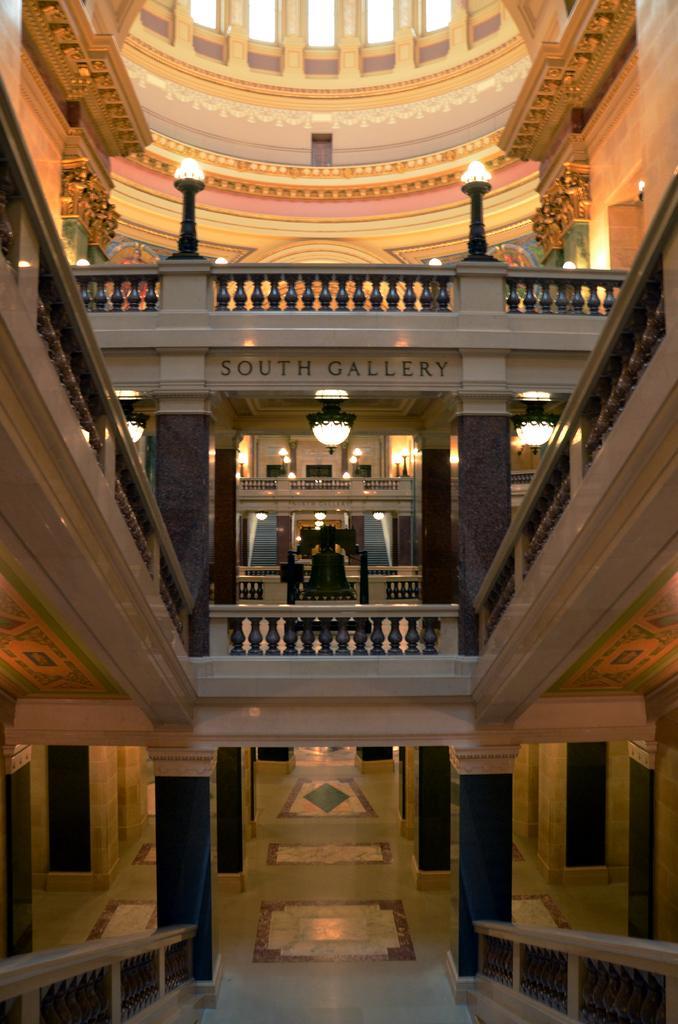How would you summarize this image in a sentence or two? In this image I can see a building. Background I can see few lights and the wall is in brown and cream color. 